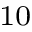<formula> <loc_0><loc_0><loc_500><loc_500>^ { 1 0 }</formula> 